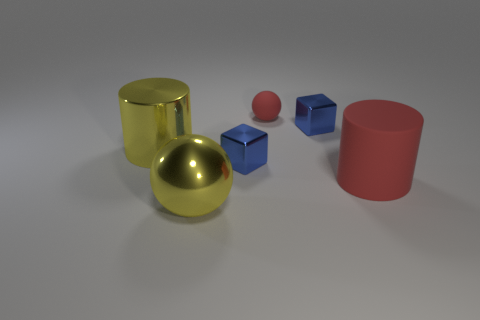There is another thing that is the same shape as the big matte object; what is it made of?
Provide a succinct answer. Metal. Is there anything else that is made of the same material as the yellow cylinder?
Make the answer very short. Yes. What number of yellow things are either big cylinders or big balls?
Offer a very short reply. 2. What material is the red thing in front of the yellow metal cylinder?
Ensure brevity in your answer.  Rubber. Are there more big green cubes than yellow objects?
Your answer should be compact. No. There is a big metal object that is behind the big red matte cylinder; is its shape the same as the small red matte object?
Keep it short and to the point. No. What number of metallic blocks are in front of the yellow metallic cylinder and on the right side of the tiny rubber sphere?
Provide a succinct answer. 0. What number of other red rubber objects are the same shape as the small matte thing?
Ensure brevity in your answer.  0. What is the color of the cylinder that is in front of the blue block left of the small red thing?
Offer a very short reply. Red. There is a tiny matte thing; is it the same shape as the tiny object on the right side of the tiny ball?
Ensure brevity in your answer.  No. 